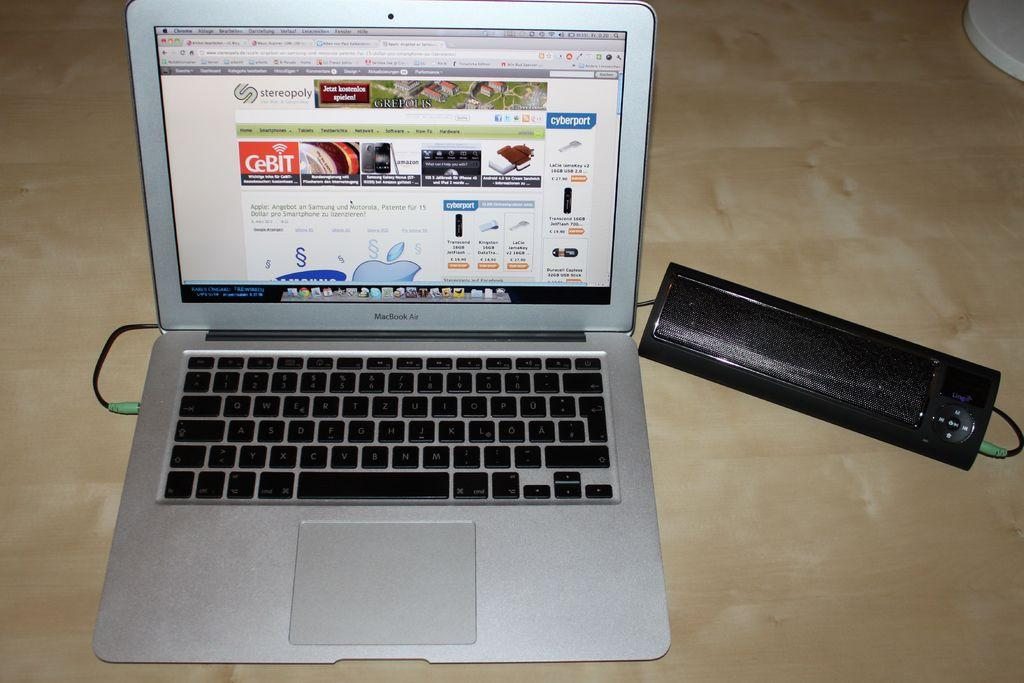<image>
Give a short and clear explanation of the subsequent image. A MacBook Air is open on a wooden surface. 